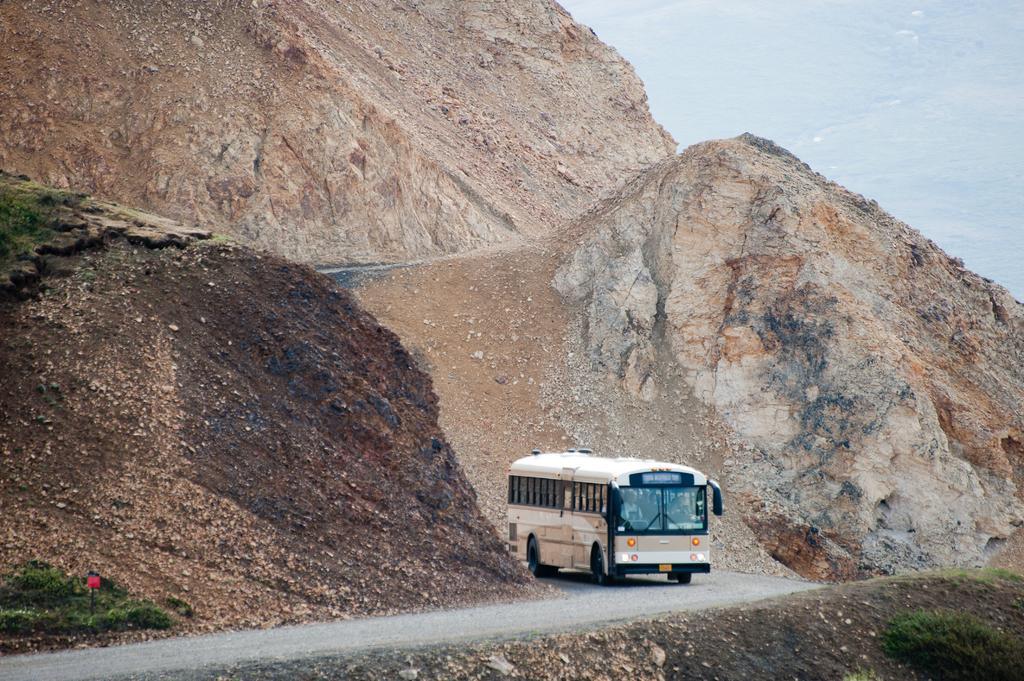How would you summarize this image in a sentence or two? In this image, I can see a bus on the road and there are mountains. At the bottom left and right side of the image, I can see the plants. 